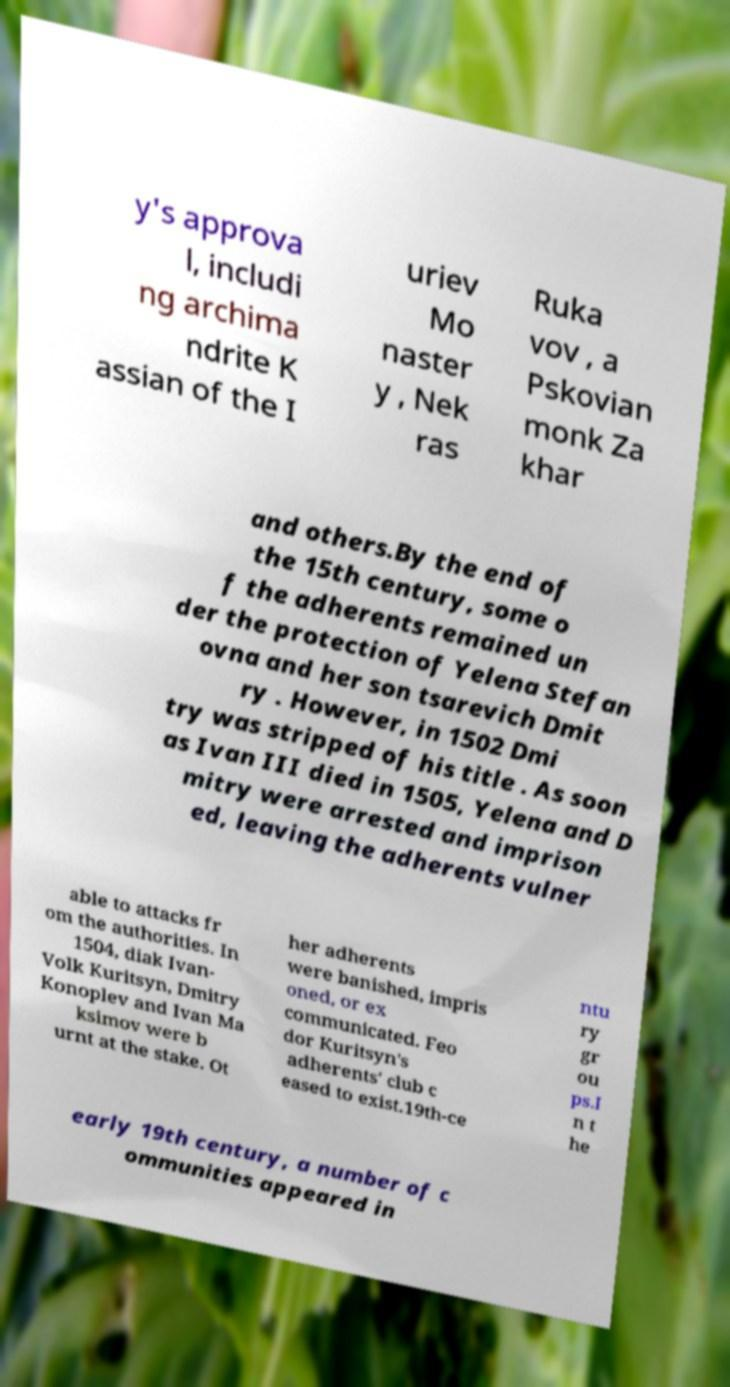What messages or text are displayed in this image? I need them in a readable, typed format. y's approva l, includi ng archima ndrite K assian of the I uriev Mo naster y , Nek ras Ruka vov , a Pskovian monk Za khar and others.By the end of the 15th century, some o f the adherents remained un der the protection of Yelena Stefan ovna and her son tsarevich Dmit ry . However, in 1502 Dmi try was stripped of his title . As soon as Ivan III died in 1505, Yelena and D mitry were arrested and imprison ed, leaving the adherents vulner able to attacks fr om the authorities. In 1504, diak Ivan- Volk Kuritsyn, Dmitry Konoplev and Ivan Ma ksimov were b urnt at the stake. Ot her adherents were banished, impris oned, or ex communicated. Feo dor Kuritsyn's adherents' club c eased to exist.19th-ce ntu ry gr ou ps.I n t he early 19th century, a number of c ommunities appeared in 